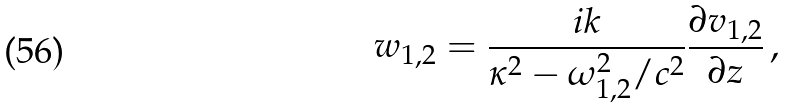Convert formula to latex. <formula><loc_0><loc_0><loc_500><loc_500>w _ { 1 , 2 } = \frac { i k } { \kappa ^ { 2 } - \omega _ { 1 , 2 } ^ { 2 } / c ^ { 2 } } \frac { \partial v _ { 1 , 2 } } { \partial z } \, ,</formula> 